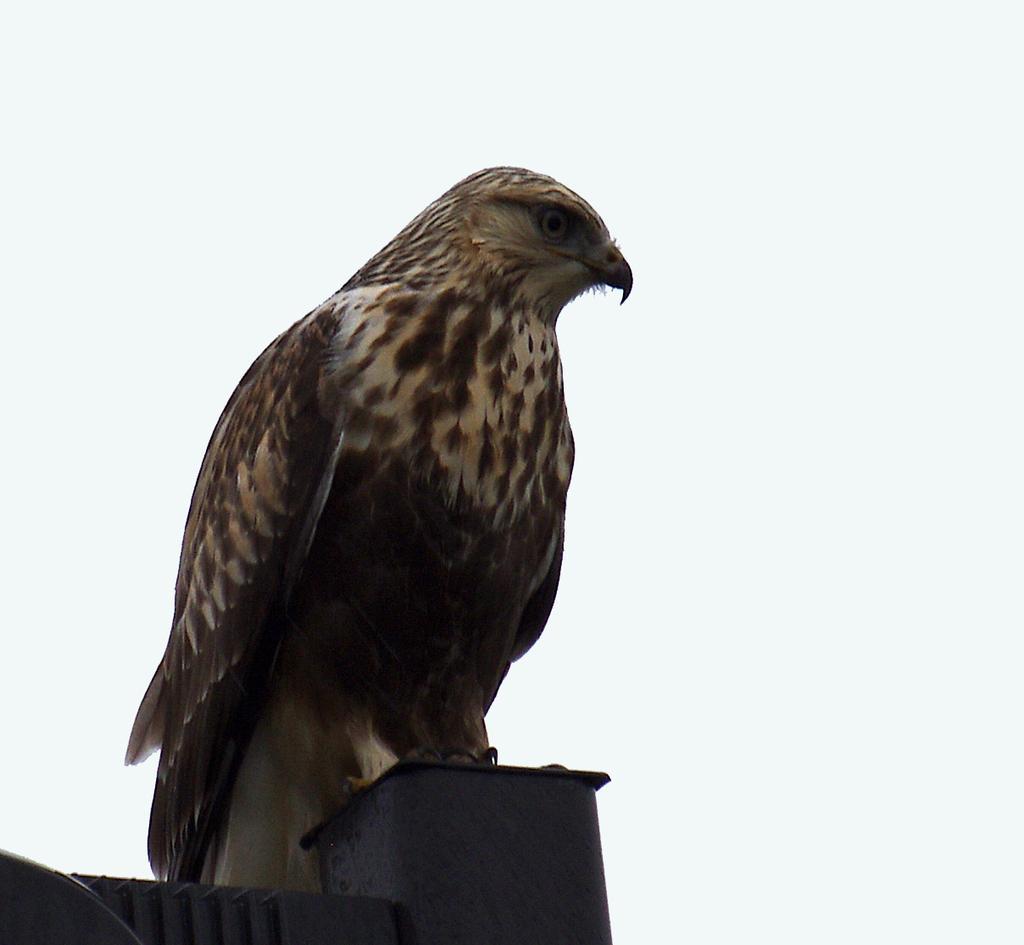How would you summarize this image in a sentence or two? In this image I can see a bird which is in cream, black and brown color. It is on the black color object. And here is a white background. 